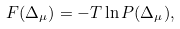Convert formula to latex. <formula><loc_0><loc_0><loc_500><loc_500>F ( \Delta _ { \mu } ) = - T \ln P ( \Delta _ { \mu } ) ,</formula> 